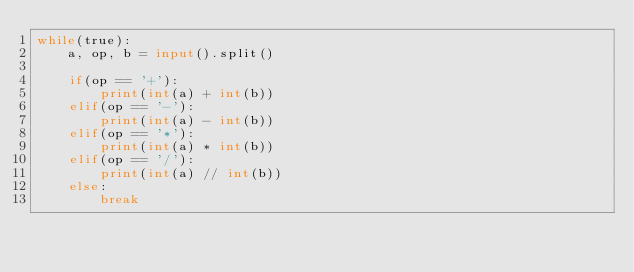Convert code to text. <code><loc_0><loc_0><loc_500><loc_500><_Python_>while(true):
    a, op, b = input().split()

    if(op == '+'):
        print(int(a) + int(b))
    elif(op == '-'):
        print(int(a) - int(b))
    elif(op == '*'):
        print(int(a) * int(b))
    elif(op == '/'):
        print(int(a) // int(b))
    else:
        break
</code> 